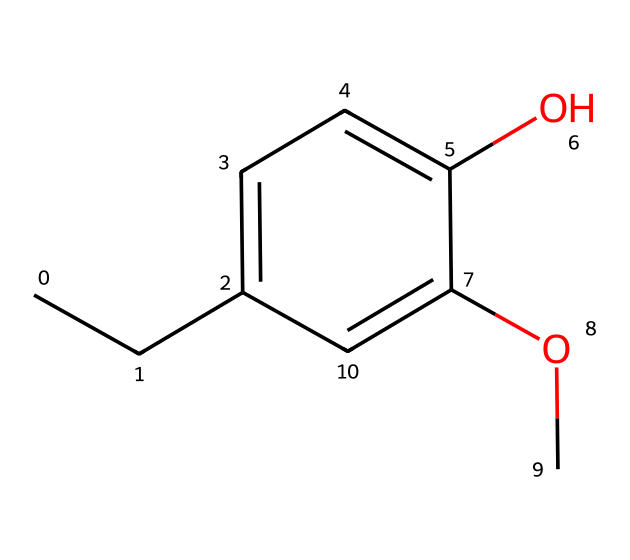What is the molecular formula of eugenol? By analyzing the SMILES representation, the structure includes 10 carbon atoms, 12 hydrogen atoms, and 2 oxygen atoms, leading to the molecular formula C10H12O2.
Answer: C10H12O2 How many rings does this compound have? The SMILES representation indicates that there is a benzene ring present in the structure, making it a single-ring compound.
Answer: 1 What functional groups are present in eugenol? The structure contains a hydroxyl (-OH) group and a methoxy (-OCH3) group, which are typical functional groups found in this aromatic compound.
Answer: hydroxyl and methoxy Which element is present in the highest quantity? Upon counting the atoms in the molecular formula, there are 10 carbon atoms, 12 hydrogen atoms, and 2 oxygen atoms; thus, hydrogen is the most abundant element.
Answer: hydrogen What type of compound is eugenol classified as? Given its aromatic structure with a phenolic component (due to the -OH group attached to the ring), it is classified as an aromatic alcohol.
Answer: aromatic alcohol How many double bonds are in the aromatic ring of eugenol? The benzene ring structure in this compound consists of three alternating double bonds, which are characteristic of aromatic compounds.
Answer: 3 Does eugenol contain any heteroatoms? In the provided SMILES structure, all atoms are carbon, hydrogen, and oxygen; hence there are no heteroatoms other than the oxygen.
Answer: no 